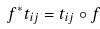<formula> <loc_0><loc_0><loc_500><loc_500>f ^ { * } t _ { i j } = t _ { i j } \circ f</formula> 